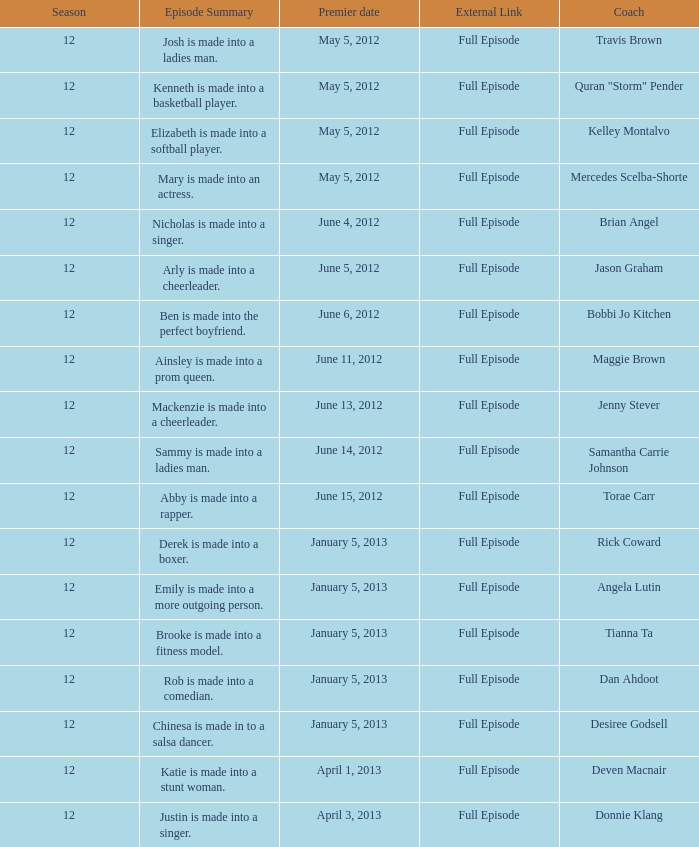Who is the trainer that helps emily become a more outgoing personality? Angela Lutin. 